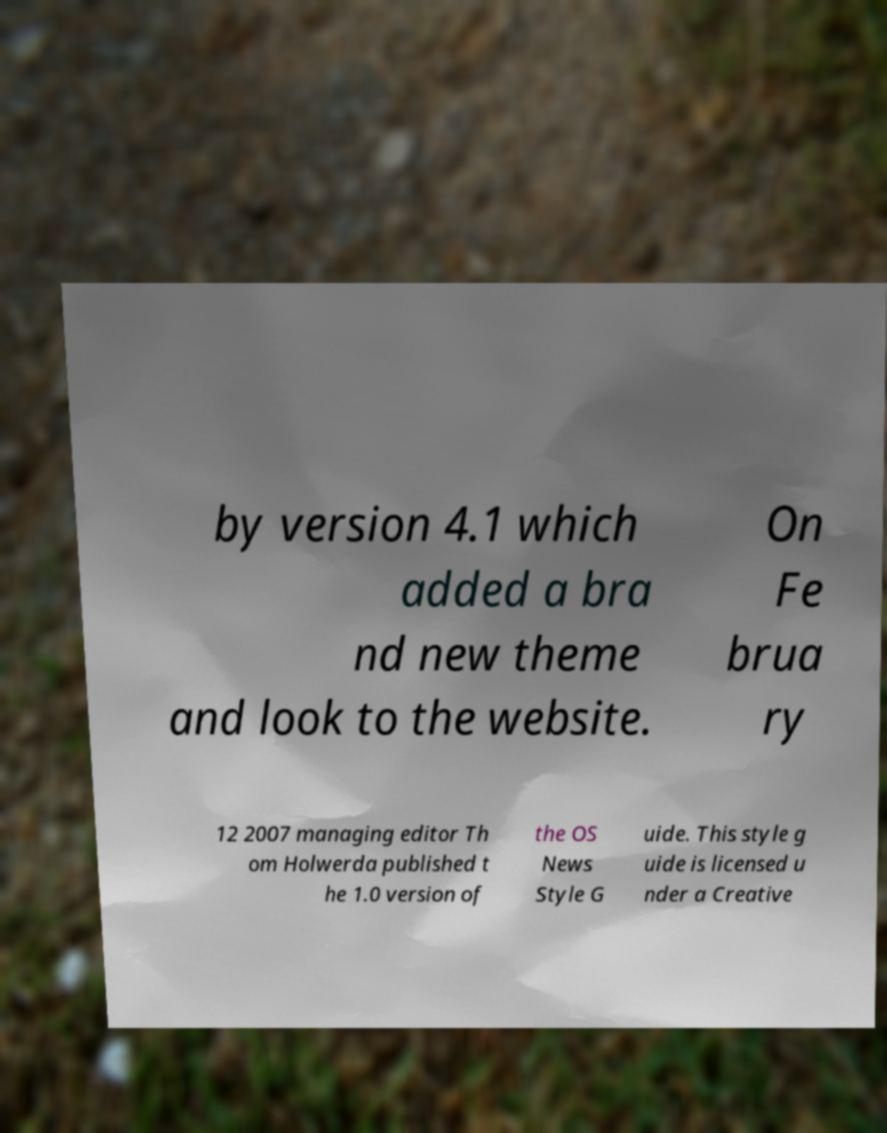I need the written content from this picture converted into text. Can you do that? by version 4.1 which added a bra nd new theme and look to the website. On Fe brua ry 12 2007 managing editor Th om Holwerda published t he 1.0 version of the OS News Style G uide. This style g uide is licensed u nder a Creative 